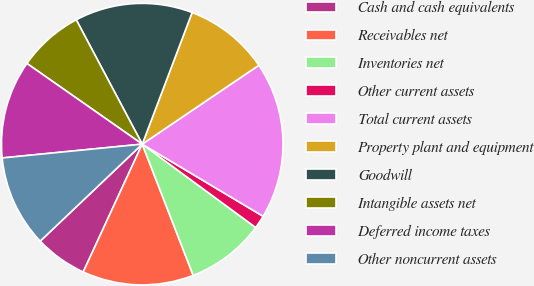Convert chart to OTSL. <chart><loc_0><loc_0><loc_500><loc_500><pie_chart><fcel>Cash and cash equivalents<fcel>Receivables net<fcel>Inventories net<fcel>Other current assets<fcel>Total current assets<fcel>Property plant and equipment<fcel>Goodwill<fcel>Intangible assets net<fcel>Deferred income taxes<fcel>Other noncurrent assets<nl><fcel>6.02%<fcel>12.78%<fcel>9.02%<fcel>1.52%<fcel>18.03%<fcel>9.77%<fcel>13.53%<fcel>7.52%<fcel>11.28%<fcel>10.53%<nl></chart> 